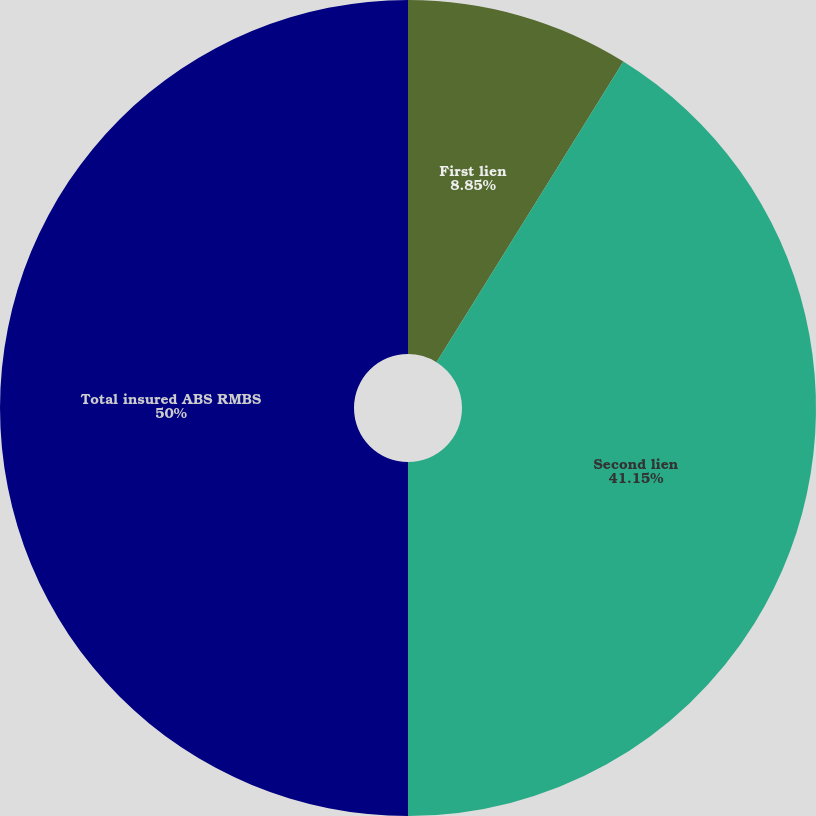Convert chart. <chart><loc_0><loc_0><loc_500><loc_500><pie_chart><fcel>First lien<fcel>Second lien<fcel>Total insured ABS RMBS<nl><fcel>8.85%<fcel>41.15%<fcel>50.0%<nl></chart> 